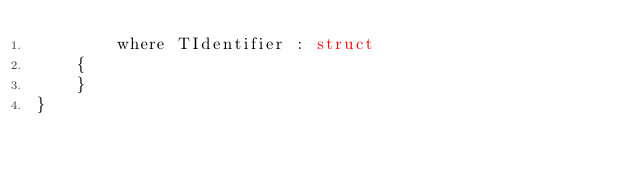Convert code to text. <code><loc_0><loc_0><loc_500><loc_500><_C#_>        where TIdentifier : struct
    {
    }
}</code> 